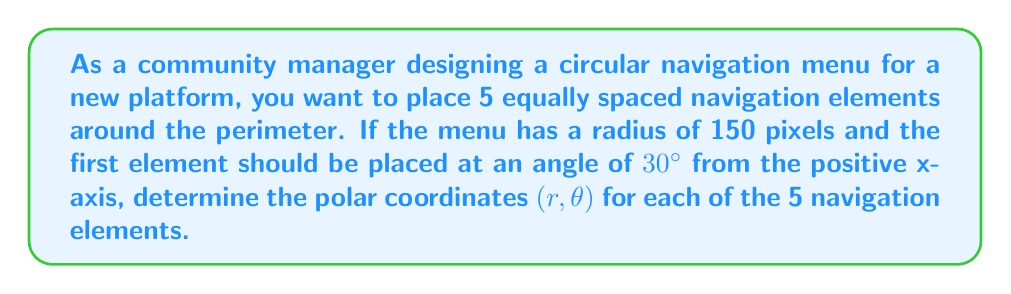Provide a solution to this math problem. To solve this problem, we'll follow these steps:

1) First, we need to determine the angular spacing between each element. Since there are 5 elements and they should be equally spaced around a full circle (360°), the angle between each element will be:

   $\Delta \theta = \frac{360°}{5} = 72°$

2) Now, we can calculate the angle for each element, starting from the given 30°:

   Element 1: $30°$
   Element 2: $30° + 72° = 102°$
   Element 3: $102° + 72° = 174°$
   Element 4: $174° + 72° = 246°$
   Element 5: $246° + 72° = 318°$

3) The radius for all elements is given as 150 pixels.

4) Now we can express each element's position in polar coordinates $(r, \theta)$:

   Element 1: $(150, 30°)$
   Element 2: $(150, 102°)$
   Element 3: $(150, 174°)$
   Element 4: $(150, 246°)$
   Element 5: $(150, 318°)$

[asy]
size(200);
draw(circle((0,0),150));
for(int i=0; i<5; ++i) {
  real angle = radians(30+72*i);
  dot(150*dir(angle));
  label("$"+(i+1)+"$", 165*dir(angle));
}
draw((0,0)--(150,0), arrow=Arrow(TeXHead));
draw((0,0)--(0,150), arrow=Arrow(TeXHead));
label("$x$", (160,0), E);
label("$y$", (0,160), N);
[/asy]

This diagram illustrates the placement of the 5 navigation elements on the circular menu.
Answer: The polar coordinates $(r, \theta)$ for the 5 navigation elements are:
1. $(150, 30°)$
2. $(150, 102°)$
3. $(150, 174°)$
4. $(150, 246°)$
5. $(150, 318°)$ 